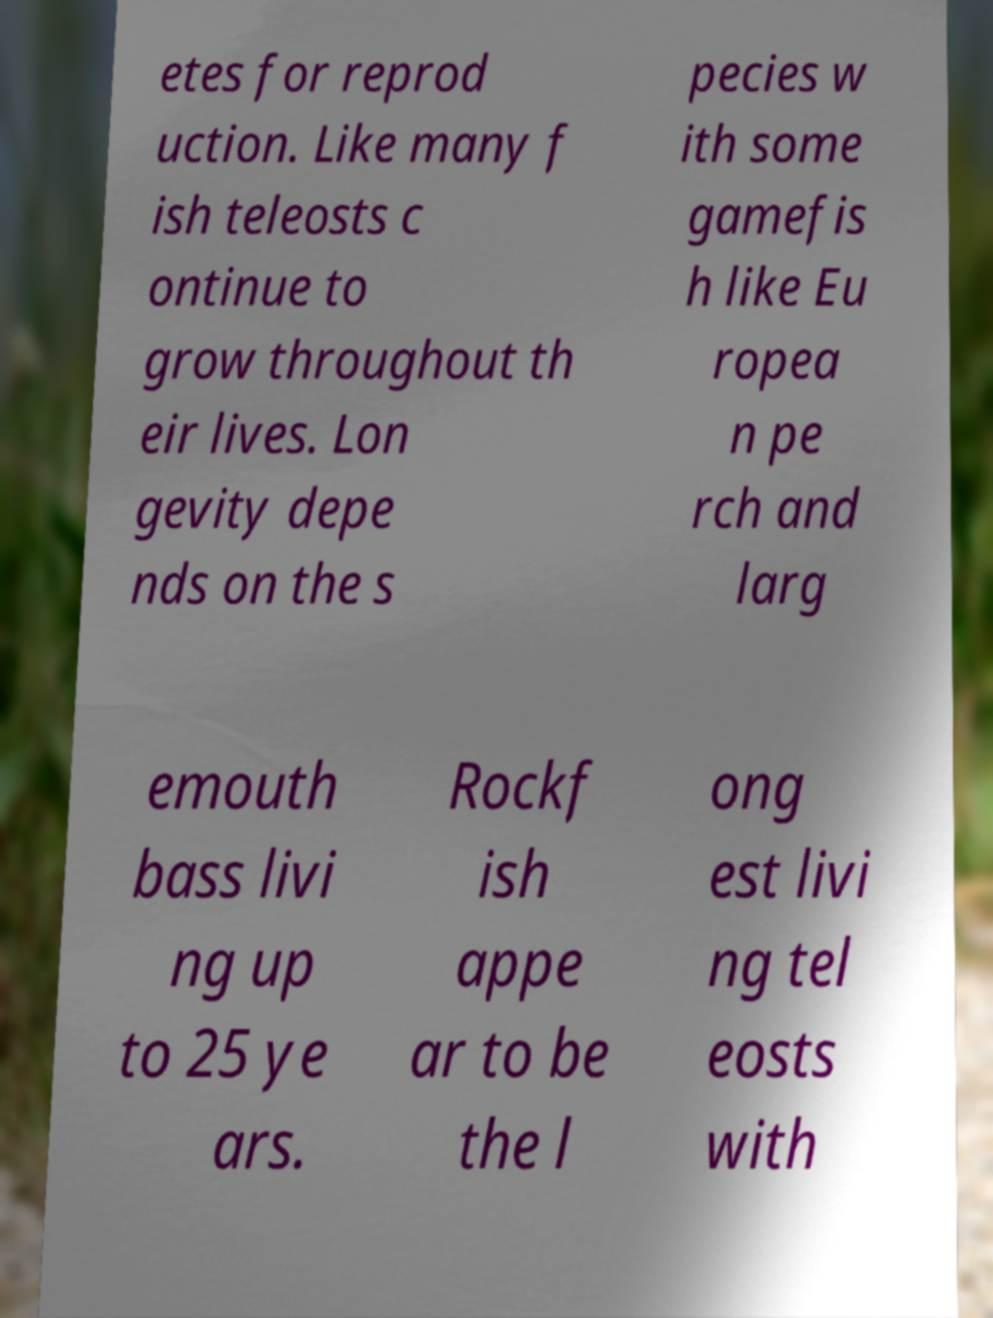Please read and relay the text visible in this image. What does it say? etes for reprod uction. Like many f ish teleosts c ontinue to grow throughout th eir lives. Lon gevity depe nds on the s pecies w ith some gamefis h like Eu ropea n pe rch and larg emouth bass livi ng up to 25 ye ars. Rockf ish appe ar to be the l ong est livi ng tel eosts with 